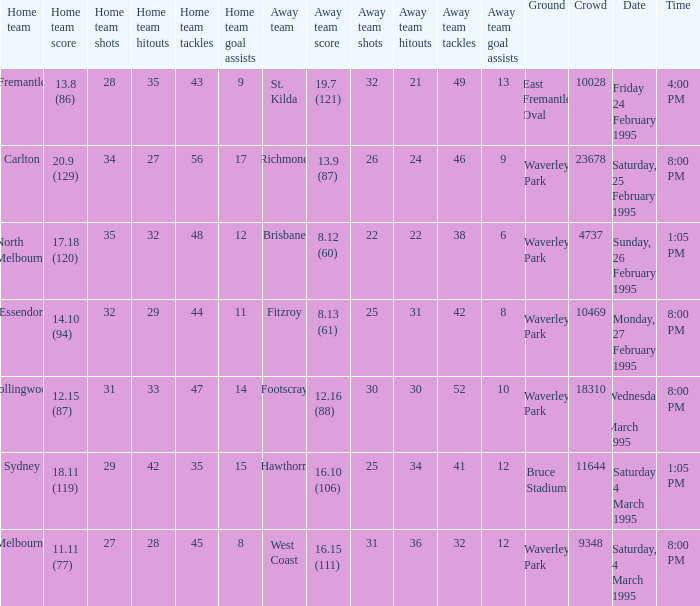Name the total number of grounds for essendon 1.0. 